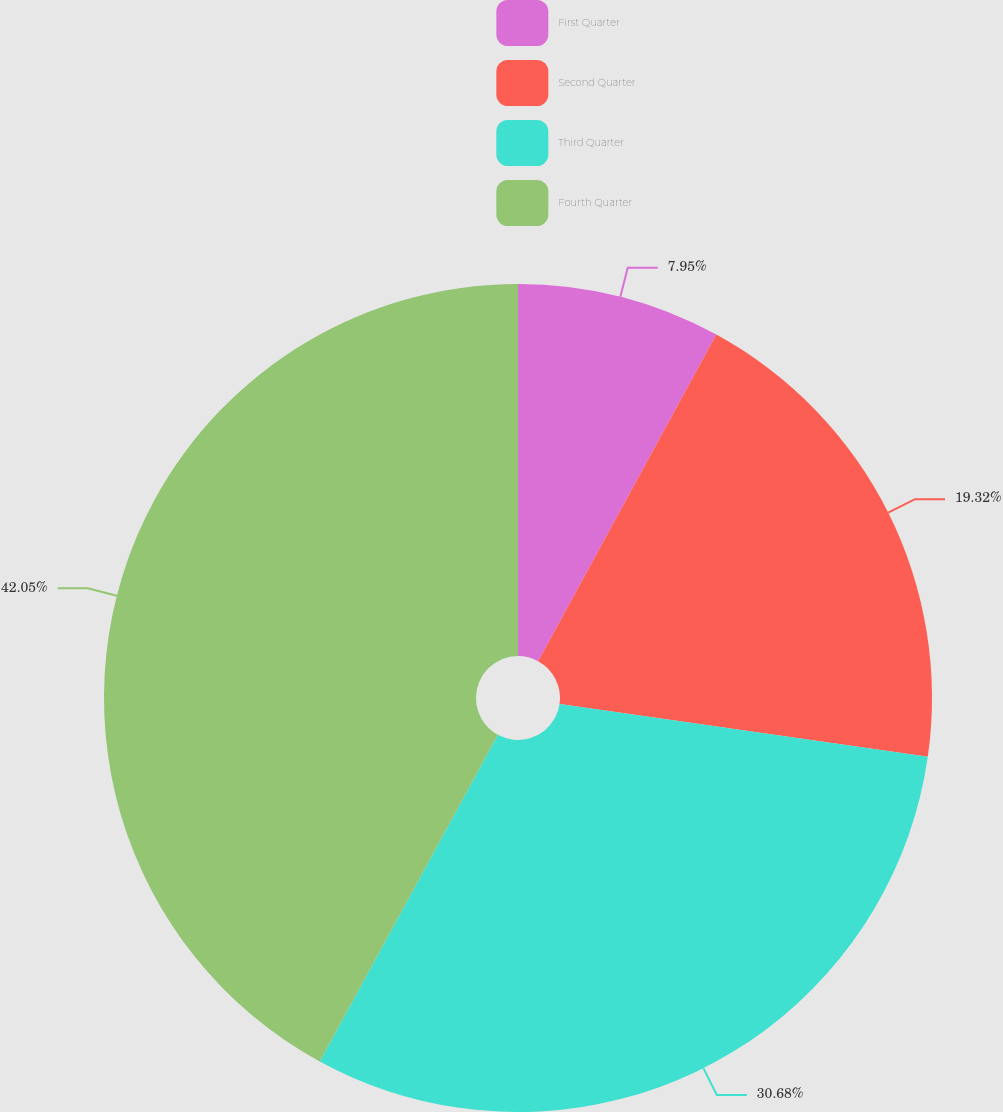Convert chart. <chart><loc_0><loc_0><loc_500><loc_500><pie_chart><fcel>First Quarter<fcel>Second Quarter<fcel>Third Quarter<fcel>Fourth Quarter<nl><fcel>7.95%<fcel>19.32%<fcel>30.68%<fcel>42.05%<nl></chart> 